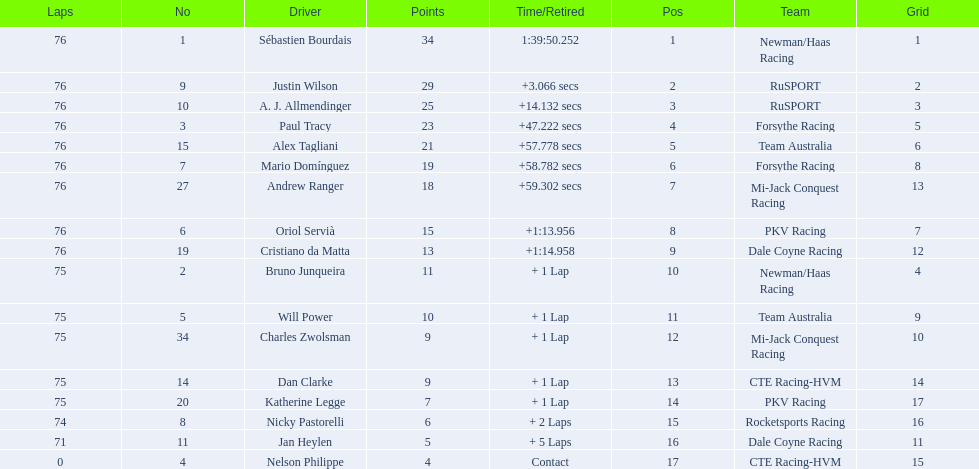Which drivers completed all 76 laps? Sébastien Bourdais, Justin Wilson, A. J. Allmendinger, Paul Tracy, Alex Tagliani, Mario Domínguez, Andrew Ranger, Oriol Servià, Cristiano da Matta. Of these drivers, which ones finished less than a minute behind first place? Paul Tracy, Alex Tagliani, Mario Domínguez, Andrew Ranger. Of these drivers, which ones finished with a time less than 50 seconds behind first place? Justin Wilson, A. J. Allmendinger, Paul Tracy. Of these three drivers, who finished last? Paul Tracy. 